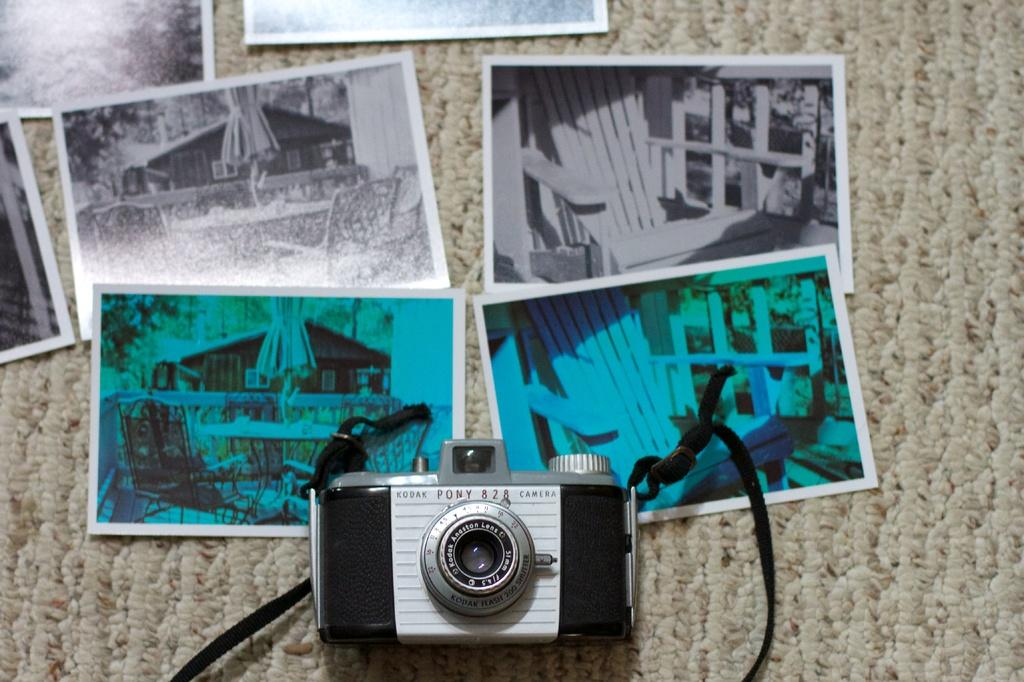What is the main object in the image? There is a camera in the image. What else can be seen in the image besides the camera? There are photos in the image. Can you describe the background of the image? The background of the image is cream-colored. What type of curtain is hanging in front of the camera in the image? There is no curtain present in the image; it only features a camera and photos. 